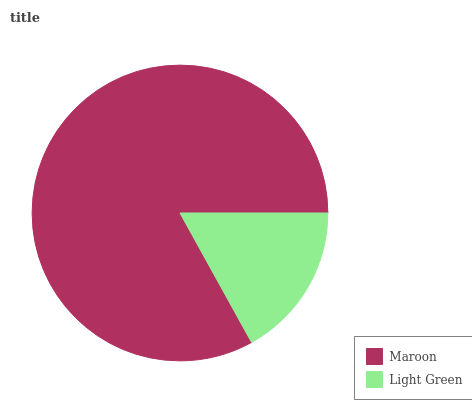Is Light Green the minimum?
Answer yes or no. Yes. Is Maroon the maximum?
Answer yes or no. Yes. Is Light Green the maximum?
Answer yes or no. No. Is Maroon greater than Light Green?
Answer yes or no. Yes. Is Light Green less than Maroon?
Answer yes or no. Yes. Is Light Green greater than Maroon?
Answer yes or no. No. Is Maroon less than Light Green?
Answer yes or no. No. Is Maroon the high median?
Answer yes or no. Yes. Is Light Green the low median?
Answer yes or no. Yes. Is Light Green the high median?
Answer yes or no. No. Is Maroon the low median?
Answer yes or no. No. 